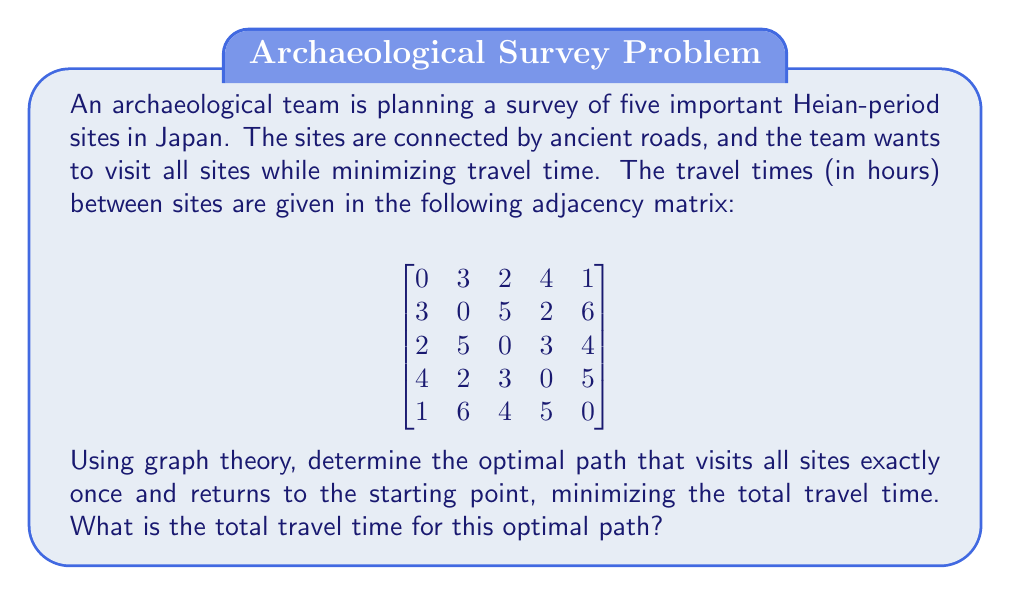Help me with this question. This problem is an instance of the Traveling Salesman Problem (TSP) applied to archaeological survey planning. We can solve it using the following steps:

1) First, we recognize that this is a complete graph with 5 vertices (sites) and 10 edges (roads).

2) The total number of possible Hamiltonian cycles (paths that visit each vertex once and return to the start) is $(5-1)!/2 = 12$ distinct cycles.

3) We can enumerate all these cycles and calculate the total travel time for each:

   (1-2-3-4-5-1): 3 + 5 + 3 + 5 + 1 = 17 hours
   (1-2-4-3-5-1): 3 + 2 + 3 + 4 + 1 = 13 hours
   (1-2-4-5-3-1): 3 + 2 + 5 + 4 + 2 = 16 hours
   (1-3-2-4-5-1): 2 + 5 + 2 + 5 + 1 = 15 hours
   (1-3-4-2-5-1): 2 + 3 + 2 + 6 + 1 = 14 hours
   (1-3-4-5-2-1): 2 + 3 + 5 + 6 + 3 = 19 hours
   (1-3-5-2-4-1): 2 + 4 + 6 + 2 + 4 = 18 hours
   (1-3-5-4-2-1): 2 + 4 + 5 + 2 + 3 = 16 hours
   (1-4-2-3-5-1): 4 + 2 + 5 + 4 + 1 = 16 hours
   (1-4-3-2-5-1): 4 + 3 + 5 + 6 + 1 = 19 hours
   (1-4-5-2-3-1): 4 + 5 + 6 + 5 + 2 = 22 hours
   (1-5-2-3-4-1): 1 + 6 + 5 + 3 + 4 = 19 hours

4) The optimal path is the one with the minimum total travel time, which is 1-2-4-3-5-1 with a total time of 13 hours.

This method is known as the brute-force approach to solving the TSP. For larger graphs, more efficient algorithms like dynamic programming or approximation algorithms would be necessary due to the problem's NP-hardness.
Answer: The optimal path is 1-2-4-3-5-1, with a total travel time of 13 hours. 